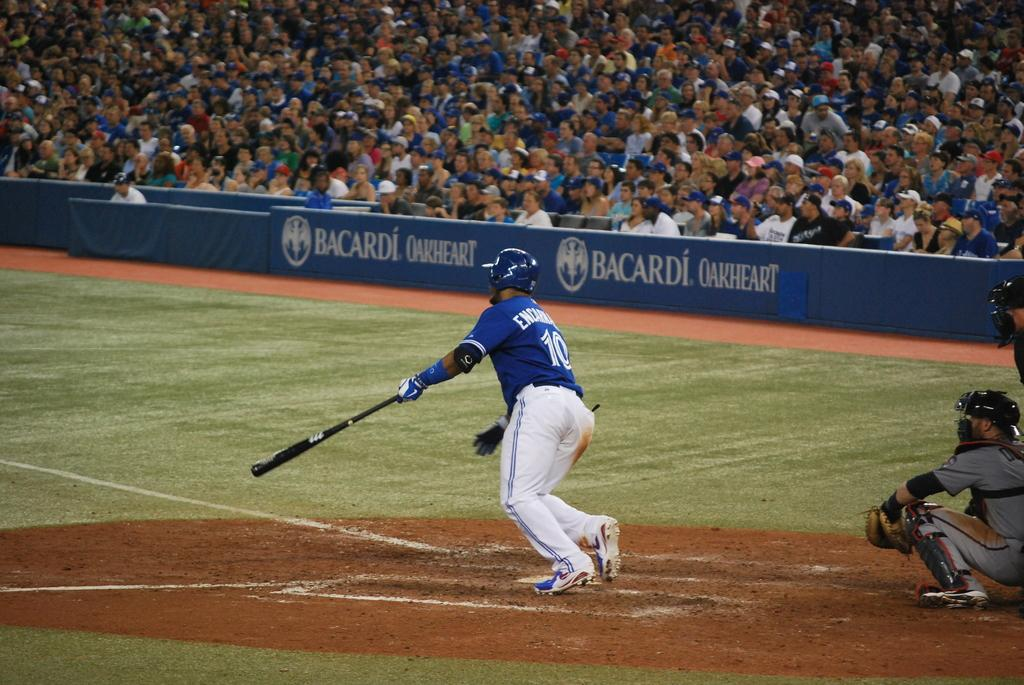Provide a one-sentence caption for the provided image. A baseball game is underway and the stadium is packed and has a Bacardi Oakheart sign. 